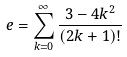<formula> <loc_0><loc_0><loc_500><loc_500>e = \sum _ { k = 0 } ^ { \infty } \frac { 3 - 4 k ^ { 2 } } { ( 2 k + 1 ) ! }</formula> 